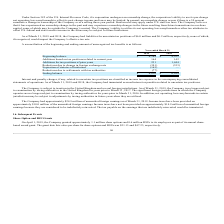From Mimecast Limited's financial document, What was the Beginning balance in 2019 and 2018 respectively? The document shows two values: $6,164 and $4,931. From the document: "Beginning balance $ 6,164 $ 4,931 Beginning balance $ 6,164 $ 4,931..." Also, What was the ending balance in 2019 and 2018 respectively? The document shows two values: $6,016 and $6,164. From the document: "Beginning balance $ 6,164 $ 4,931 Ending balance $ 6,016 $ 6,164..." Also, What was the Additions based on tax positions related to current year in 2019 and 2018 respectively? The document shows two values: 164 and 142. From the document: "ased on tax positions related to current year 164 142 ns based on tax positions related to current year 164 142..." Also, can you calculate: What was the change in the Beginning balance from 2018 to 2019? Based on the calculation: 6,164 - 4,931, the result is 1233. This is based on the information: "Beginning balance $ 6,164 $ 4,931 Beginning balance $ 6,164 $ 4,931..." The key data points involved are: 4,931, 6,164. Also, can you calculate: What was the average Additions for tax positions of prior years for 2018 and 2019? To answer this question, I need to perform calculations using the financial data. The calculation is: (231 + 1,444) / 2, which equals 837.5. This is based on the information: "Additions for tax positions of prior years 231 1,444 Additions for tax positions of prior years 231 1,444..." The key data points involved are: 1,444, 231. Additionally, In which year was Expiration of statutes of limitation less than 0? According to the financial document, 2019. The relevant text states: "2019 2018..." 